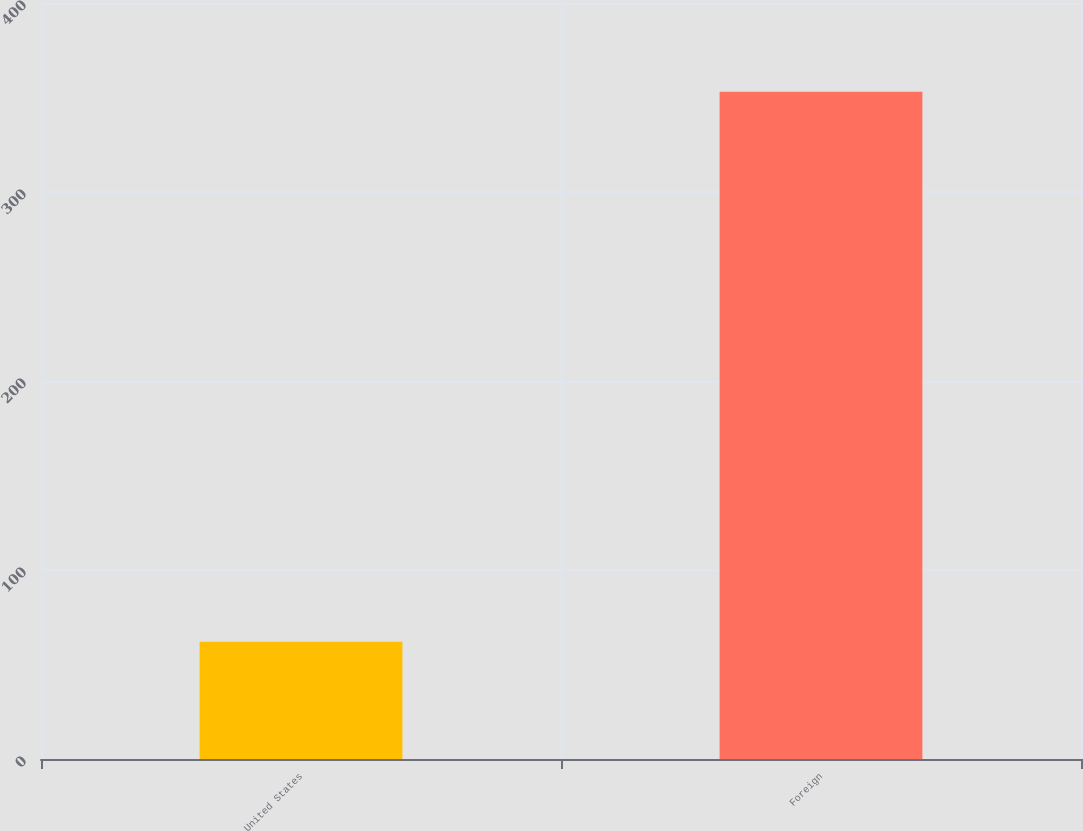Convert chart to OTSL. <chart><loc_0><loc_0><loc_500><loc_500><bar_chart><fcel>United States<fcel>Foreign<nl><fcel>62<fcel>353<nl></chart> 